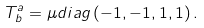Convert formula to latex. <formula><loc_0><loc_0><loc_500><loc_500>T _ { b } ^ { a } = \mu { d i a g } \left ( - 1 , - 1 , 1 , 1 \right ) .</formula> 